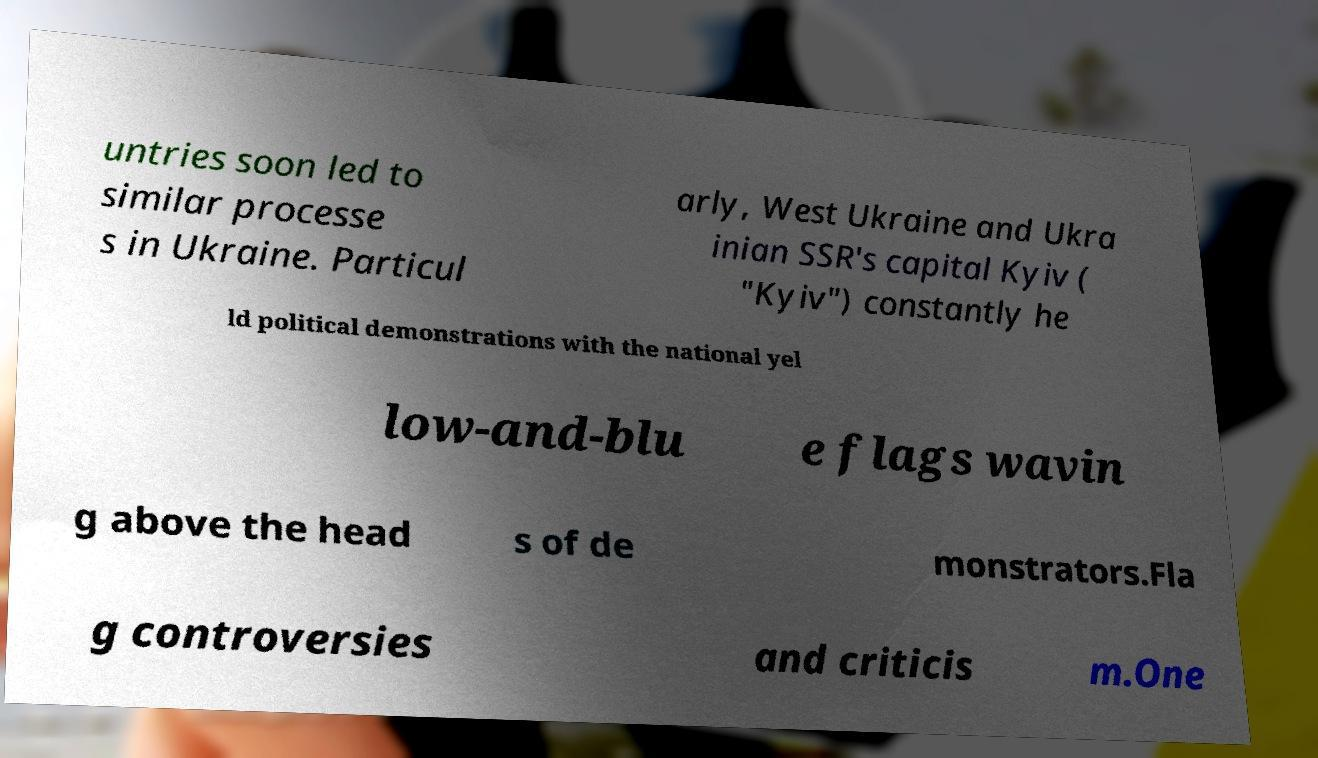Could you assist in decoding the text presented in this image and type it out clearly? untries soon led to similar processe s in Ukraine. Particul arly, West Ukraine and Ukra inian SSR's capital Kyiv ( "Kyiv") constantly he ld political demonstrations with the national yel low-and-blu e flags wavin g above the head s of de monstrators.Fla g controversies and criticis m.One 